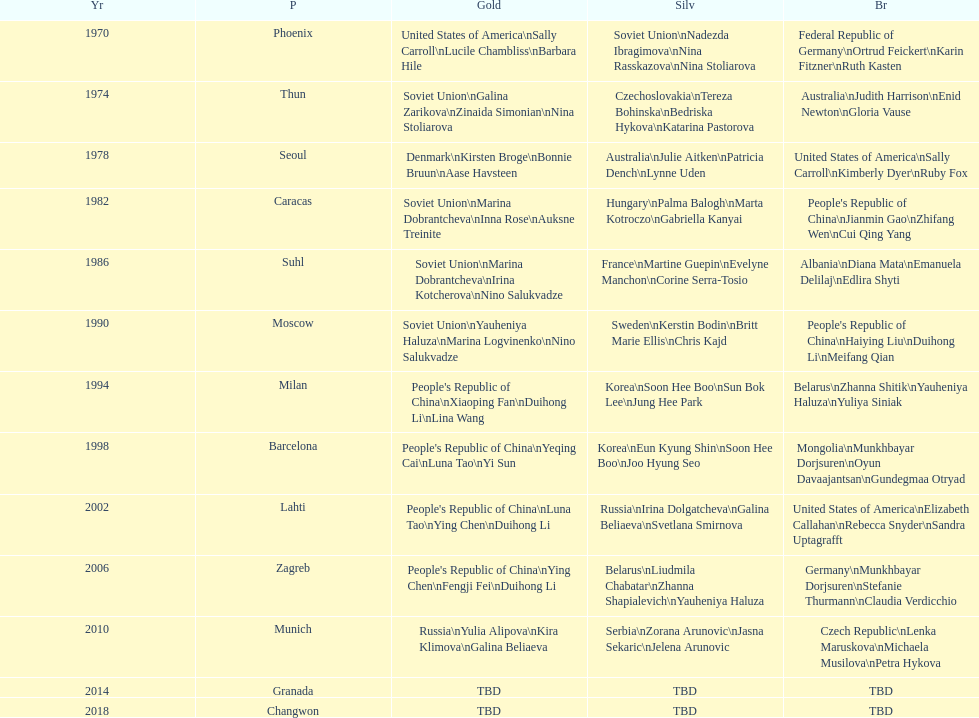Name one of the top three women to earn gold at the 1970 world championship held in phoenix, az Sally Carroll. 